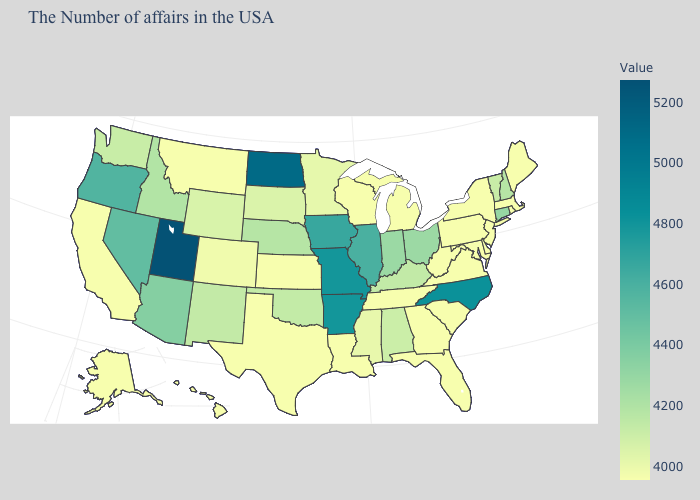Among the states that border Virginia , which have the lowest value?
Concise answer only. Maryland, West Virginia, Tennessee. Does the map have missing data?
Be succinct. No. Which states hav the highest value in the West?
Short answer required. Utah. Does Missouri have a higher value than Delaware?
Keep it brief. Yes. 